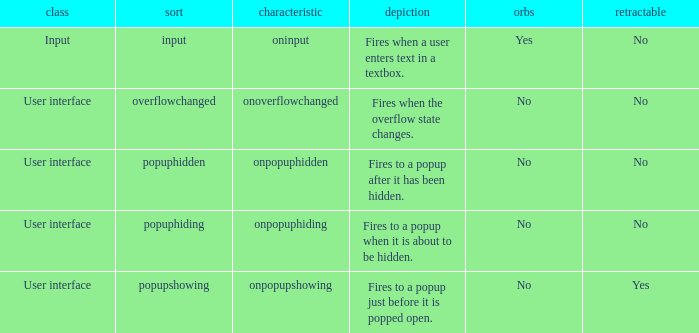What's the bubbles with attribute being onpopuphidden No. Write the full table. {'header': ['class', 'sort', 'characteristic', 'depiction', 'orbs', 'retractable'], 'rows': [['Input', 'input', 'oninput', 'Fires when a user enters text in a textbox.', 'Yes', 'No'], ['User interface', 'overflowchanged', 'onoverflowchanged', 'Fires when the overflow state changes.', 'No', 'No'], ['User interface', 'popuphidden', 'onpopuphidden', 'Fires to a popup after it has been hidden.', 'No', 'No'], ['User interface', 'popuphiding', 'onpopuphiding', 'Fires to a popup when it is about to be hidden.', 'No', 'No'], ['User interface', 'popupshowing', 'onpopupshowing', 'Fires to a popup just before it is popped open.', 'No', 'Yes']]} 